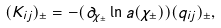<formula> <loc_0><loc_0><loc_500><loc_500>( K _ { i j } ) _ { \pm } = - ( \partial _ { \chi _ { \pm } } \ln a ( \chi _ { \pm } ) ) ( q _ { i j } ) _ { \pm } ,</formula> 